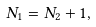<formula> <loc_0><loc_0><loc_500><loc_500>N _ { 1 } = N _ { 2 } + 1 ,</formula> 